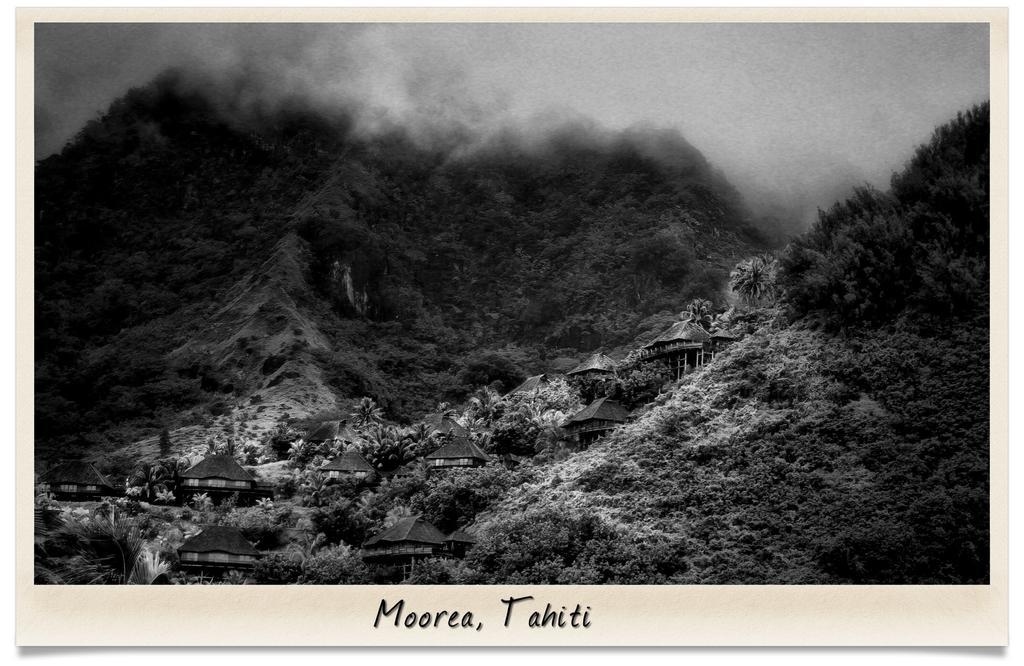Describe this image in one or two sentences. In this picture we can see some text at the bottom of the picture. There are a few houses, trees and wooden poles. Some greenery is visible in the background. 